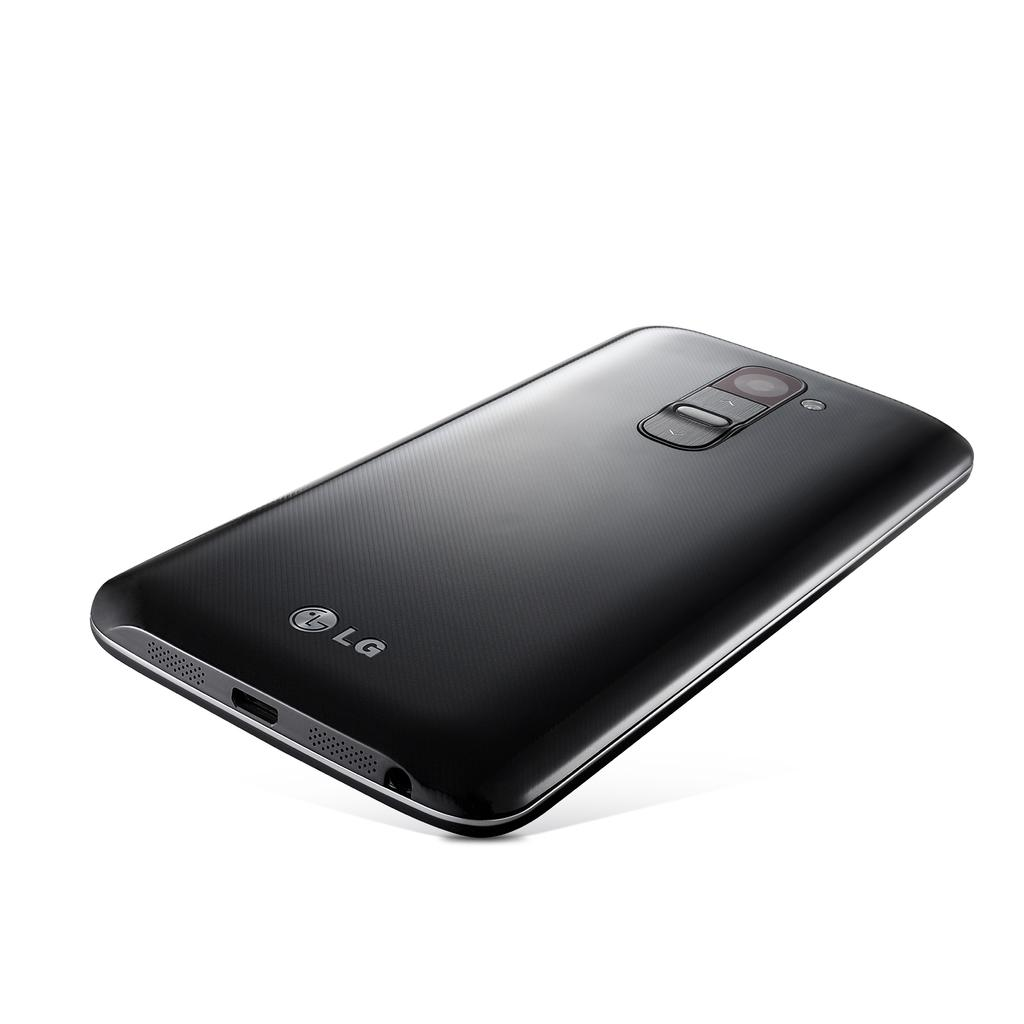<image>
Render a clear and concise summary of the photo. An LG phone is displayed face down, with the charger port toward the viewer. 